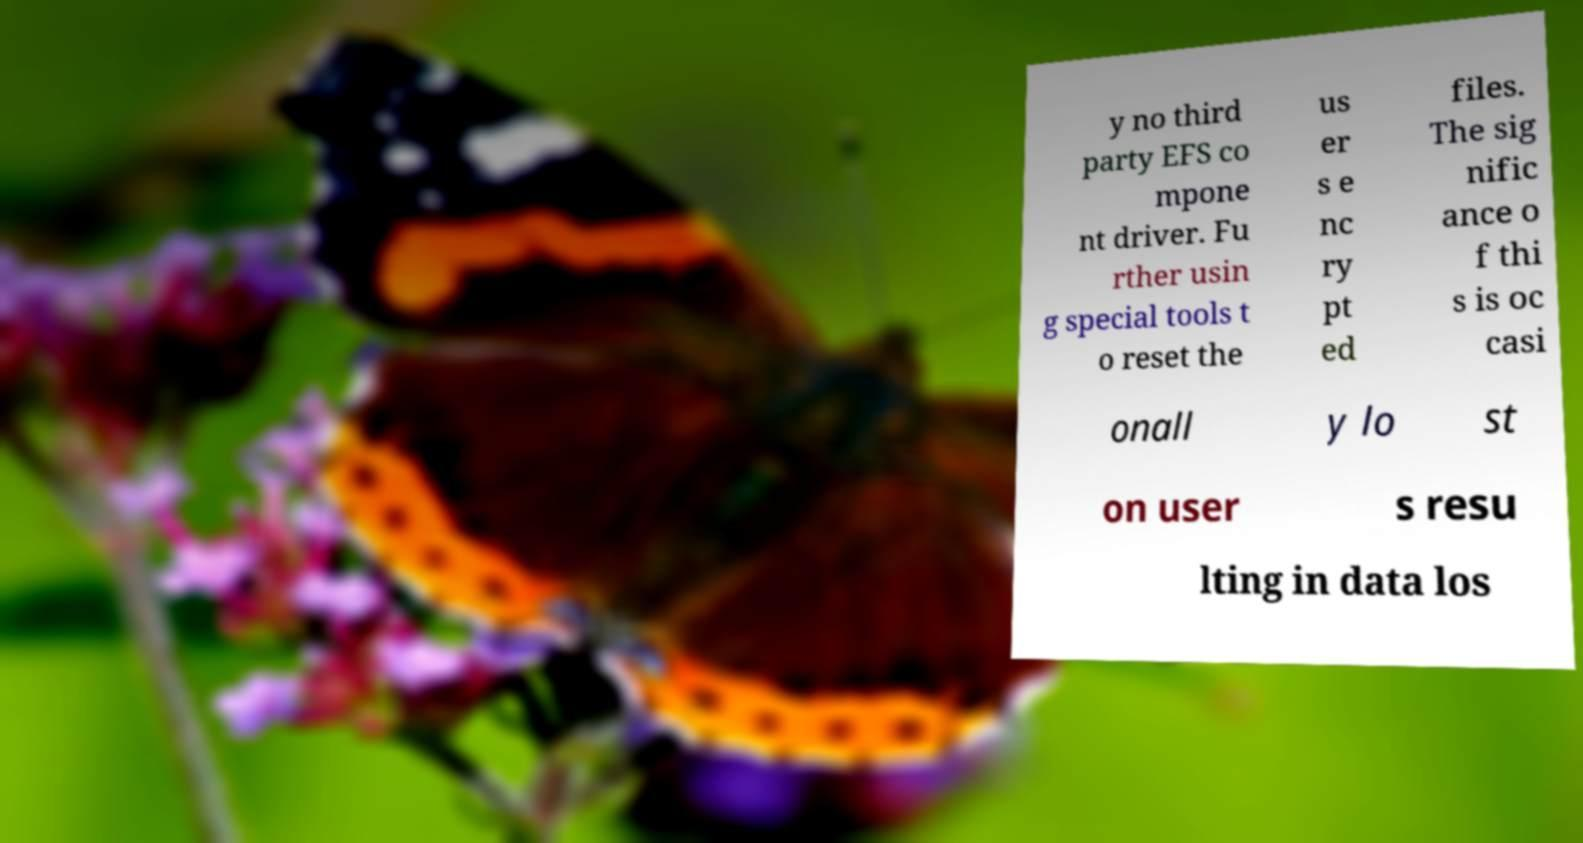Can you accurately transcribe the text from the provided image for me? y no third party EFS co mpone nt driver. Fu rther usin g special tools t o reset the us er s e nc ry pt ed files. The sig nific ance o f thi s is oc casi onall y lo st on user s resu lting in data los 